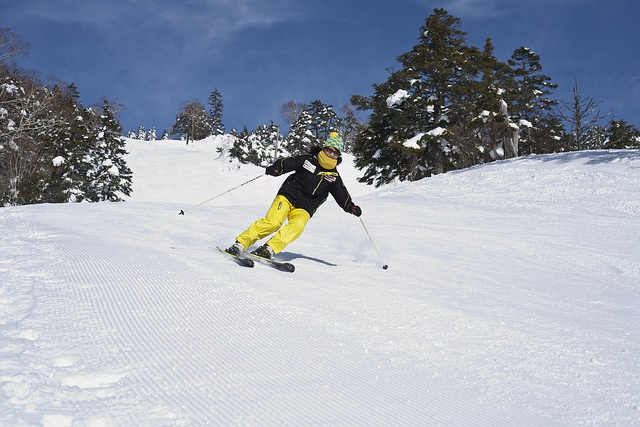Describe the objects in this image and their specific colors. I can see people in blue, black, khaki, gold, and olive tones and skis in blue, gray, darkgray, lightgray, and black tones in this image. 